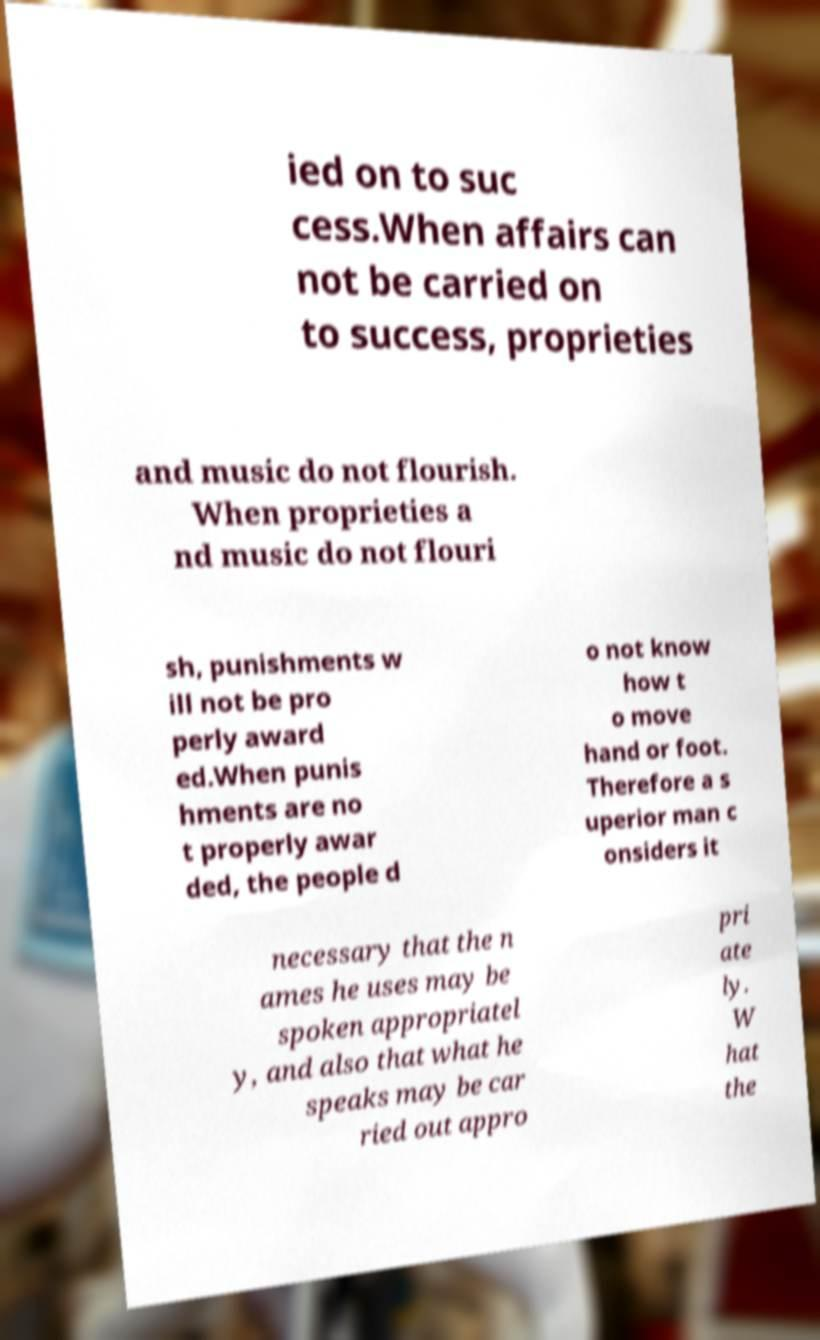Please read and relay the text visible in this image. What does it say? ied on to suc cess.When affairs can not be carried on to success, proprieties and music do not flourish. When proprieties a nd music do not flouri sh, punishments w ill not be pro perly award ed.When punis hments are no t properly awar ded, the people d o not know how t o move hand or foot. Therefore a s uperior man c onsiders it necessary that the n ames he uses may be spoken appropriatel y, and also that what he speaks may be car ried out appro pri ate ly. W hat the 